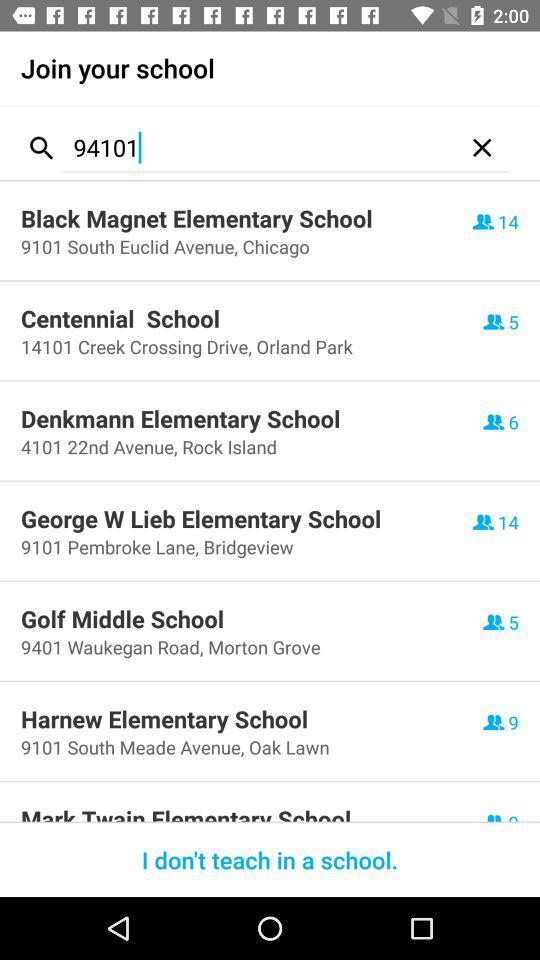Which school is located in Oak Lawn? The school that is located in Oak Lawn is "Harnew Elementary School". 